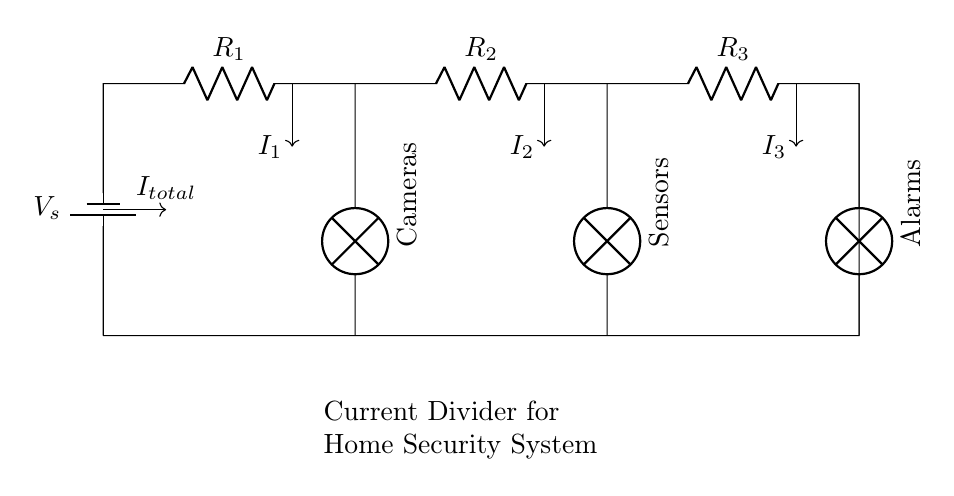What is the source voltage in the circuit? The source voltage is represented by V_s in the circuit. It provides the necessary electrical energy for the entire system.
Answer: V_s What are the resistances in the circuit? The circuit contains three resistors: R_1, R_2, and R_3. These resistances determine how the current is divided among the different branches of the circuit.
Answer: R_1, R_2, R_3 What is the total current entering the circuit? The total current entering the circuit is indicated as I_total. It is the sum of the currents flowing through each resistor in the circuit.
Answer: I_total How is the current distributed among the devices? Current is divided into three branches for Cameras, Sensors, and Alarms. The resistances R_1, R_2, and R_3 determine the amount of current flowing to each device.
Answer: Depends on resistances Which component controls the current flow to the Cameras? The current flowing to the Cameras is controlled by the resistor R_1. The amount of current going to this component is the current I_1.
Answer: R_1 Why is a current divider used in this circuit? A current divider is used to distribute the total current into smaller portions for each device (Cameras, Sensors, Alarms) without affecting overall voltage, allowing specific power requirements for each.
Answer: To distribute current 